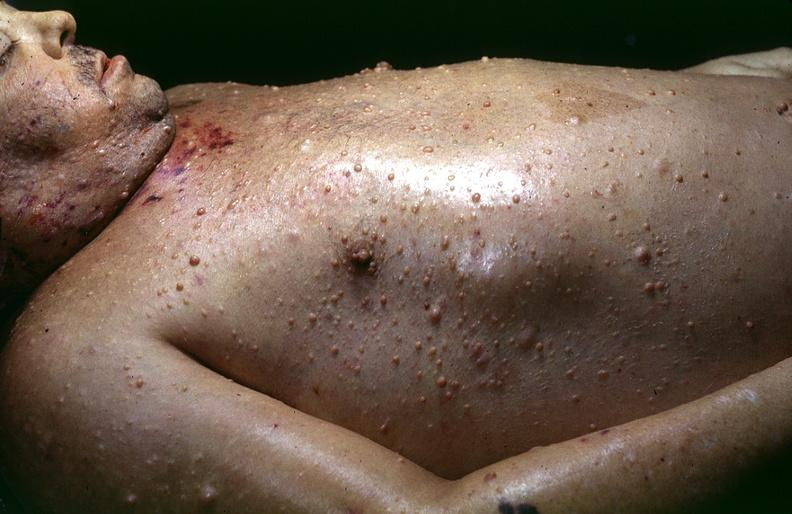does larynx show skin, neurofibromatosis?
Answer the question using a single word or phrase. No 